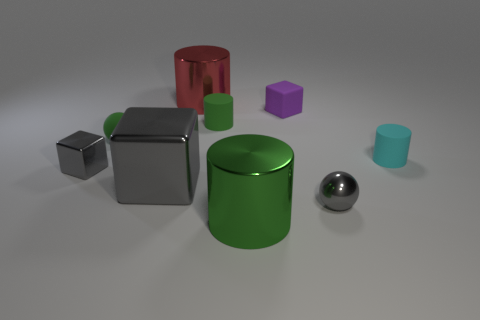What number of large objects are gray spheres or blocks?
Ensure brevity in your answer.  1. There is a metal cylinder that is the same color as the rubber ball; what size is it?
Make the answer very short. Large. Is there a big green cylinder that has the same material as the large gray cube?
Keep it short and to the point. Yes. What is the sphere that is on the left side of the purple matte object made of?
Ensure brevity in your answer.  Rubber. There is a sphere that is right of the purple rubber block; is it the same color as the small metallic object left of the red shiny cylinder?
Give a very brief answer. Yes. There is a matte cube that is the same size as the metallic sphere; what is its color?
Make the answer very short. Purple. What number of other objects are the same shape as the red object?
Provide a short and direct response. 3. There is a green thing right of the small green matte cylinder; how big is it?
Your response must be concise. Large. How many metal cylinders are to the left of the big gray metallic thing that is in front of the purple cube?
Your answer should be very brief. 0. What number of other things are there of the same size as the gray sphere?
Provide a short and direct response. 5. 